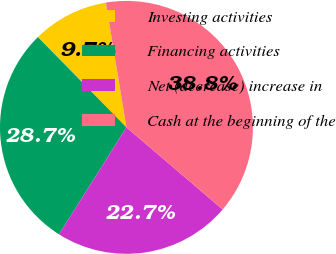<chart> <loc_0><loc_0><loc_500><loc_500><pie_chart><fcel>Investing activities<fcel>Financing activities<fcel>Net (decrease) increase in<fcel>Cash at the beginning of the<nl><fcel>9.75%<fcel>28.7%<fcel>22.71%<fcel>38.85%<nl></chart> 